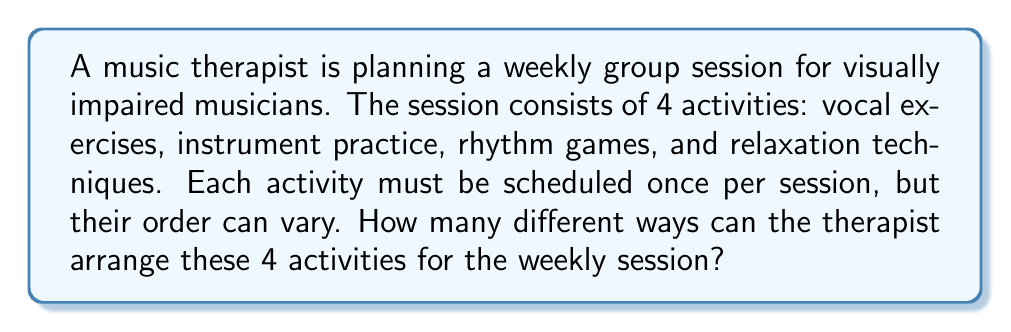Give your solution to this math problem. Let's approach this step-by-step:

1) We have 4 distinct activities that need to be arranged in a specific order.

2) This is a perfect scenario for using permutations. We're arranging all 4 activities with no repetition, and the order matters.

3) The formula for permutations of n distinct objects is:

   $$P(n) = n!$$

   Where n! (n factorial) is the product of all positive integers less than or equal to n.

4) In this case, n = 4, so we're calculating 4!

5) Let's expand this:
   
   $$4! = 4 \times 3 \times 2 \times 1 = 24$$

6) We can interpret this result as follows:
   - For the first activity, we have 4 choices
   - For the second activity, we have 3 remaining choices
   - For the third activity, we have 2 remaining choices
   - For the last activity, we only have 1 choice left

7) Multiplying these choices together gives us the total number of possible arrangements:

   $$4 \times 3 \times 2 \times 1 = 24$$

Therefore, there are 24 different ways to arrange these 4 activities for the weekly session.
Answer: 24 ways 